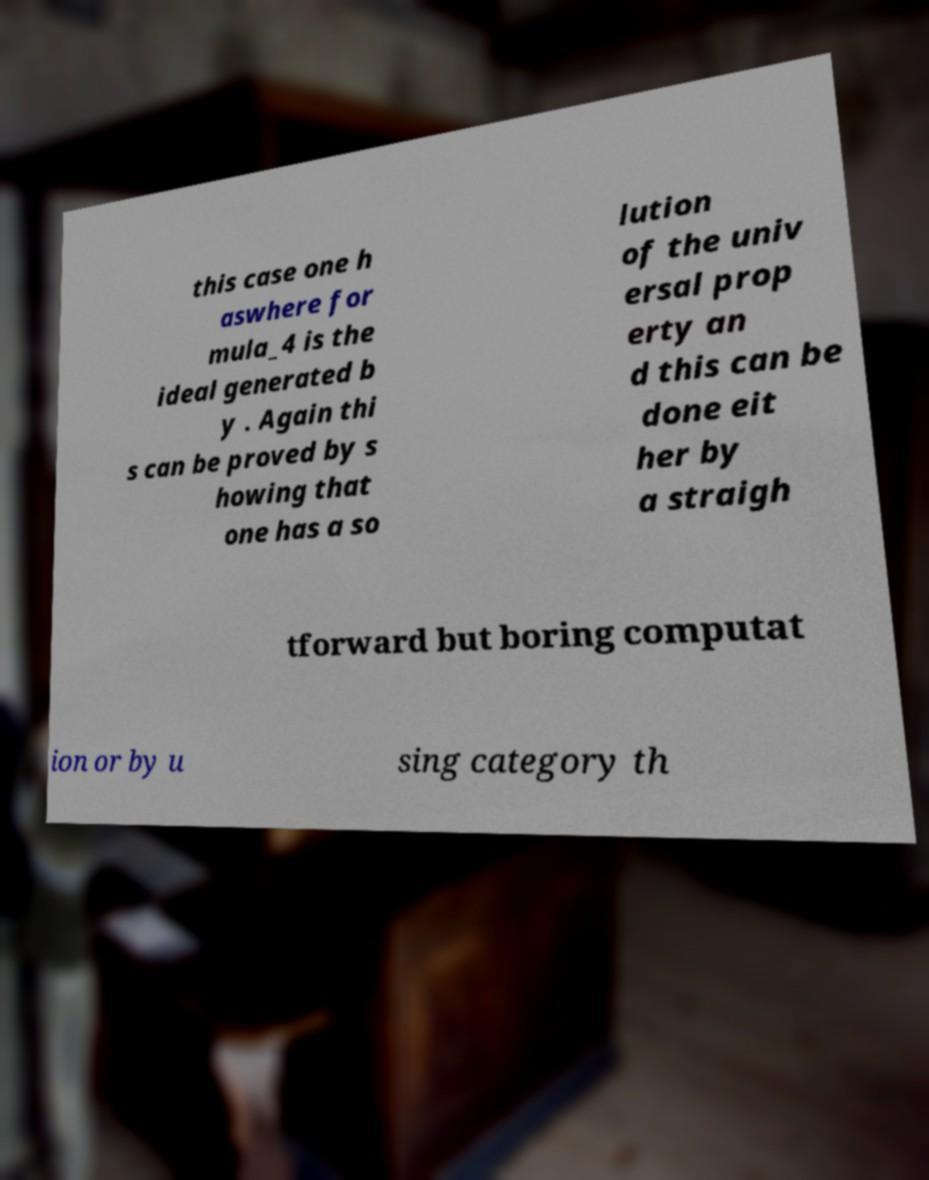Could you assist in decoding the text presented in this image and type it out clearly? this case one h aswhere for mula_4 is the ideal generated b y . Again thi s can be proved by s howing that one has a so lution of the univ ersal prop erty an d this can be done eit her by a straigh tforward but boring computat ion or by u sing category th 